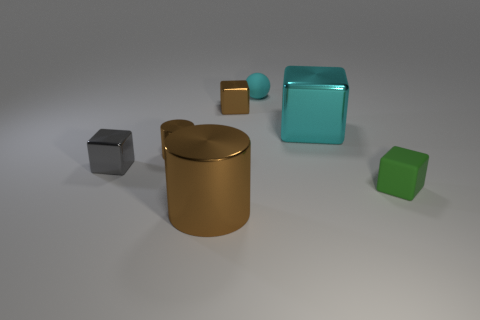Is the number of large cylinders that are to the left of the tiny gray shiny cube less than the number of big shiny cylinders?
Ensure brevity in your answer.  Yes. What number of green objects have the same size as the cyan ball?
Ensure brevity in your answer.  1. What is the shape of the tiny matte object that is the same color as the big block?
Offer a very short reply. Sphere. Does the large object that is left of the tiny cyan thing have the same color as the small metal cube that is behind the big cyan shiny block?
Provide a succinct answer. Yes. There is a matte sphere; what number of tiny things are right of it?
Offer a terse response. 1. The other cylinder that is the same color as the small cylinder is what size?
Provide a succinct answer. Large. Is there a small green thing of the same shape as the gray object?
Provide a short and direct response. Yes. What color is the matte block that is the same size as the gray metallic block?
Give a very brief answer. Green. Are there fewer gray cubes to the right of the cyan cube than brown things in front of the tiny green object?
Offer a terse response. Yes. Do the rubber object in front of the cyan matte ball and the gray metallic cube have the same size?
Make the answer very short. Yes. 